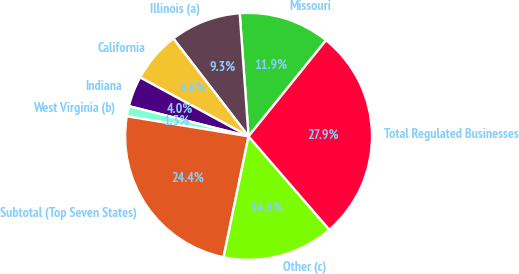<chart> <loc_0><loc_0><loc_500><loc_500><pie_chart><fcel>Missouri<fcel>Illinois (a)<fcel>California<fcel>Indiana<fcel>West Virginia (b)<fcel>Subtotal (Top Seven States)<fcel>Other (c)<fcel>Total Regulated Businesses<nl><fcel>11.94%<fcel>9.29%<fcel>6.64%<fcel>3.99%<fcel>1.33%<fcel>24.36%<fcel>14.59%<fcel>27.85%<nl></chart> 